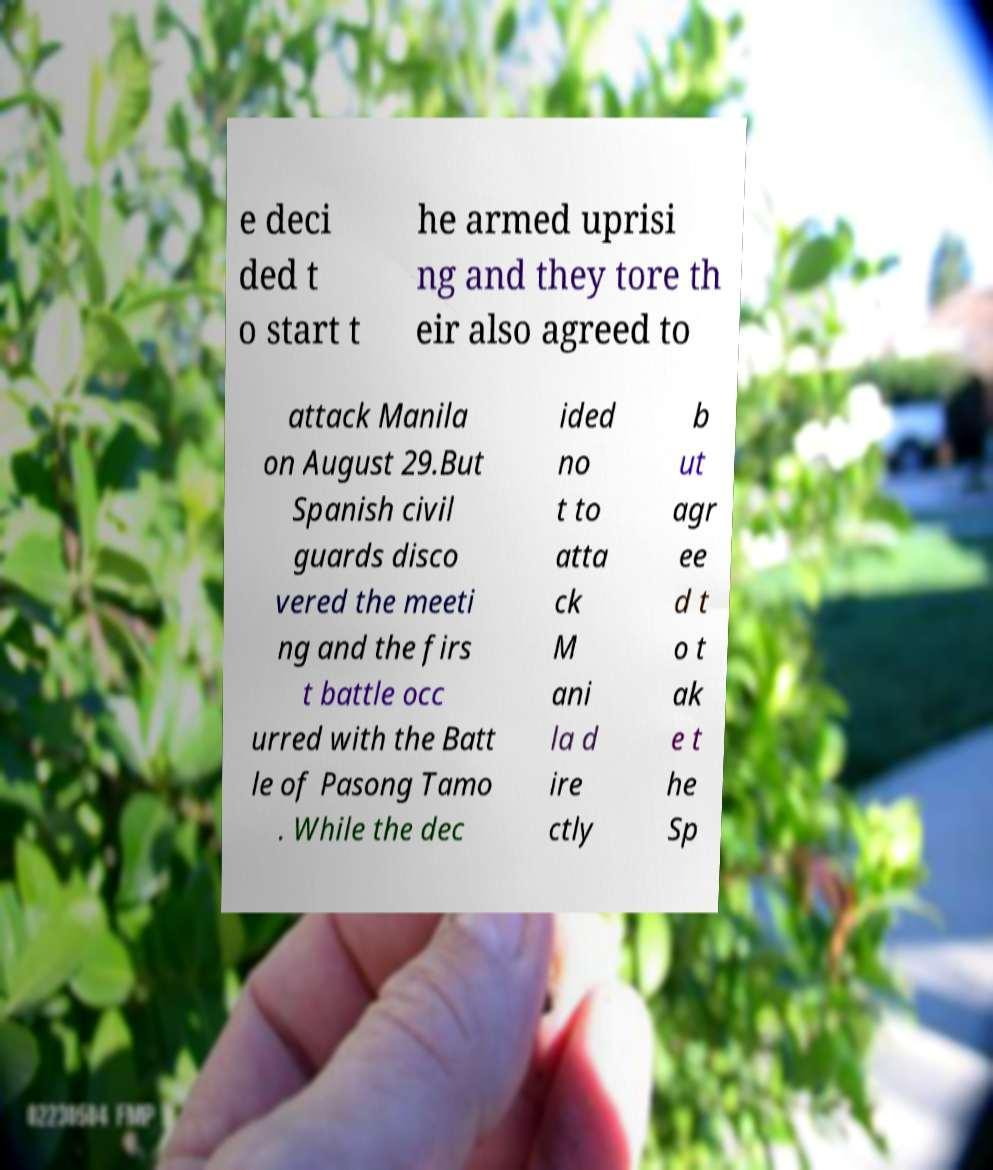Can you accurately transcribe the text from the provided image for me? e deci ded t o start t he armed uprisi ng and they tore th eir also agreed to attack Manila on August 29.But Spanish civil guards disco vered the meeti ng and the firs t battle occ urred with the Batt le of Pasong Tamo . While the dec ided no t to atta ck M ani la d ire ctly b ut agr ee d t o t ak e t he Sp 